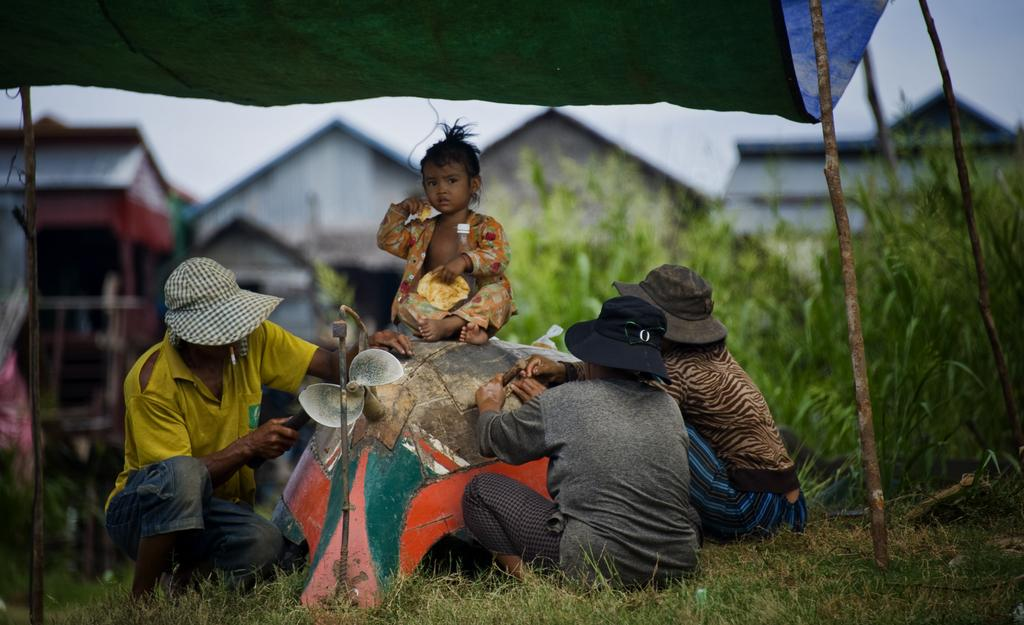How many people are on the grass in the image? There are three people on the grass in the image. What is the child doing in the image? A child is on an object in the image. What type of shelter is visible in the image? There is a tent in the image. What type of vegetation is present in the image? Plants are present in the image. What type of structures can be seen in the image? There are sheds in the image. Can you describe the background of the image? The sky is visible in the background of the image. How many beds are visible in the image? There are no beds present in the image. What type of operation is being performed on the grass in the image? There is no operation being performed in the image; it features three people on the grass and a child on an object. 